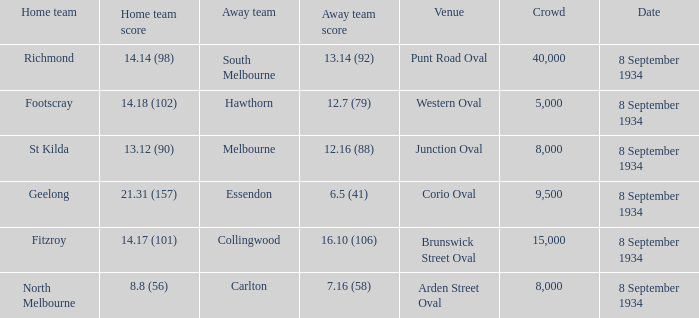Which team was considered the home team when playing at punt road oval? Richmond. 